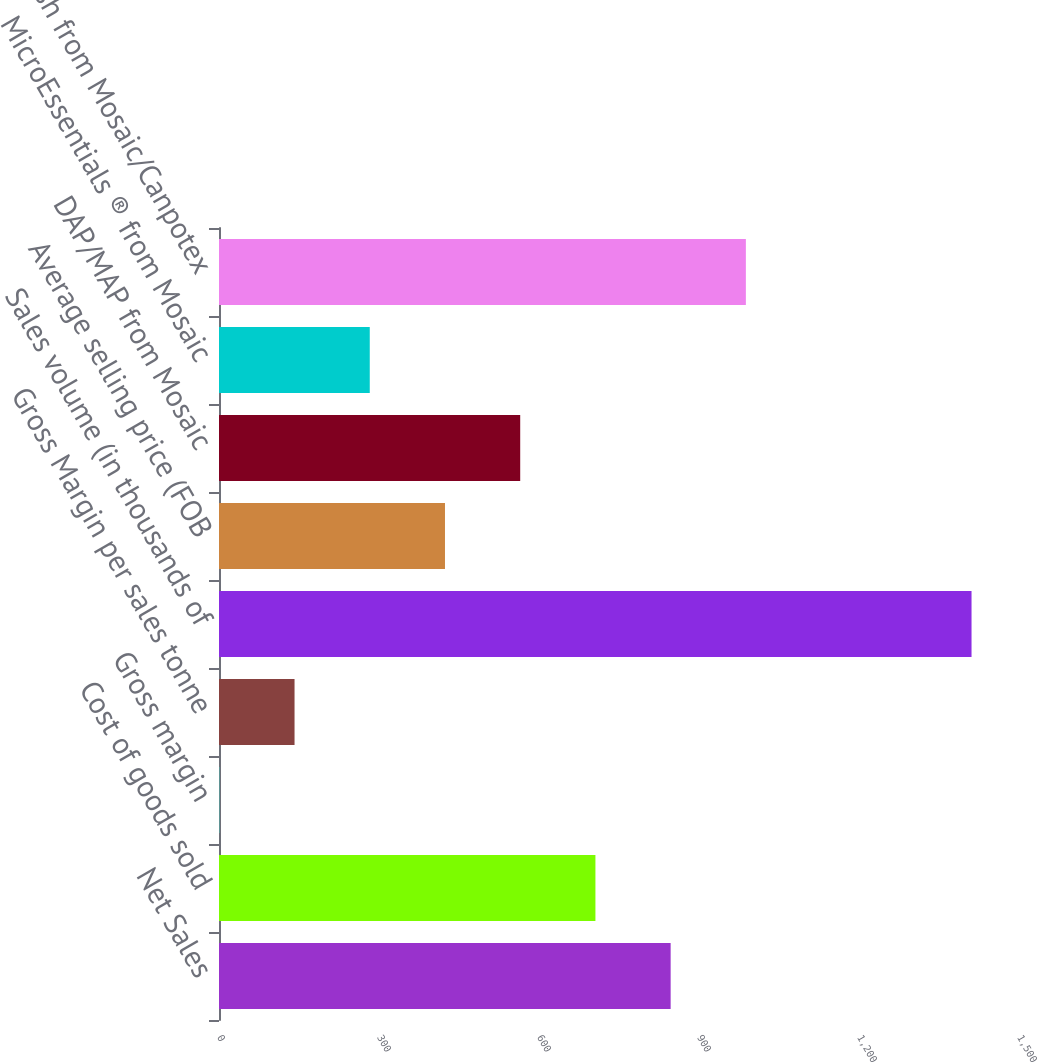Convert chart to OTSL. <chart><loc_0><loc_0><loc_500><loc_500><bar_chart><fcel>Net Sales<fcel>Cost of goods sold<fcel>Gross margin<fcel>Gross Margin per sales tonne<fcel>Sales volume (in thousands of<fcel>Average selling price (FOB<fcel>DAP/MAP from Mosaic<fcel>MicroEssentials ® from Mosaic<fcel>Potash from Mosaic/Canpotex<nl><fcel>846.84<fcel>705.8<fcel>0.6<fcel>141.64<fcel>1411<fcel>423.72<fcel>564.76<fcel>282.68<fcel>987.88<nl></chart> 